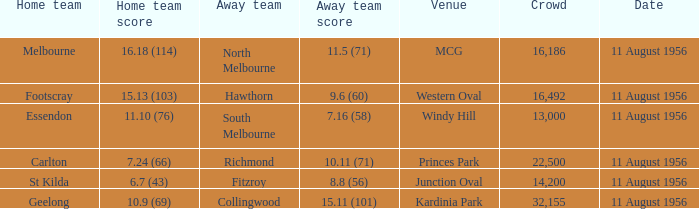Which home team participated at the western field? Footscray. 